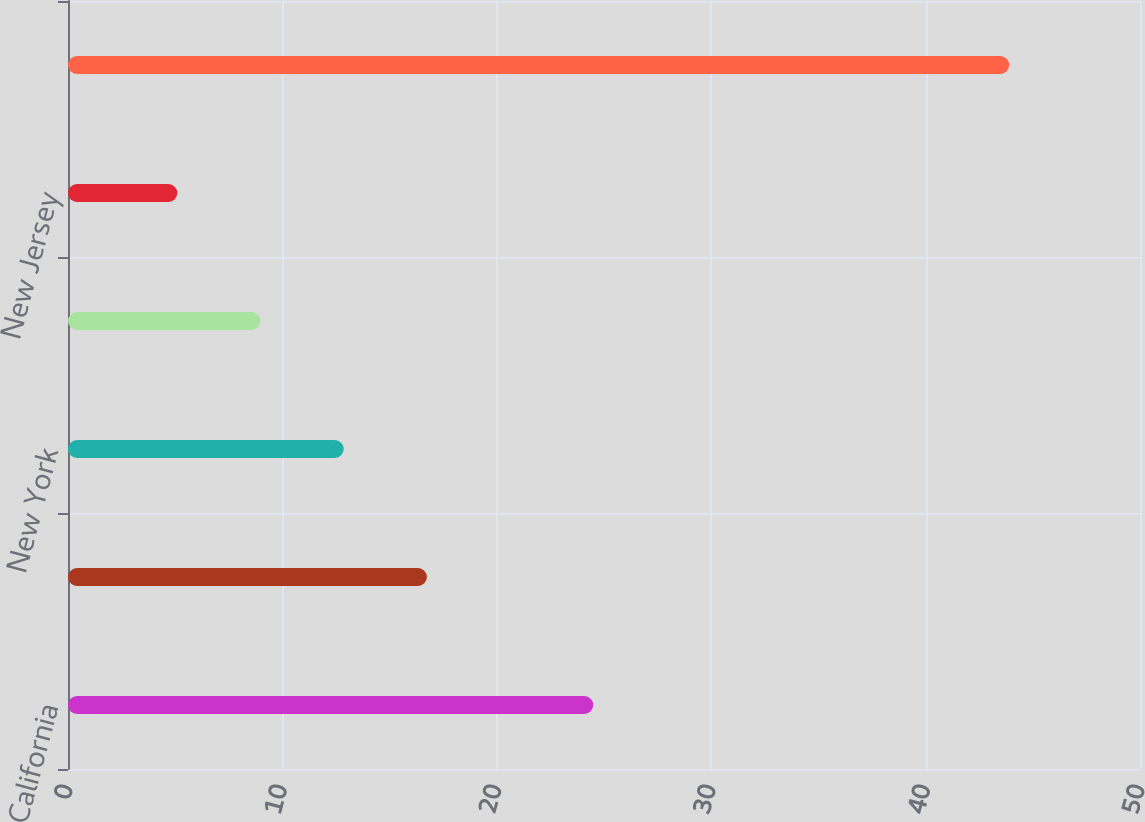<chart> <loc_0><loc_0><loc_500><loc_500><bar_chart><fcel>California<fcel>Florida<fcel>New York<fcel>Massachusetts<fcel>New Jersey<fcel>Other<nl><fcel>24.5<fcel>16.74<fcel>12.86<fcel>8.98<fcel>5.1<fcel>43.9<nl></chart> 